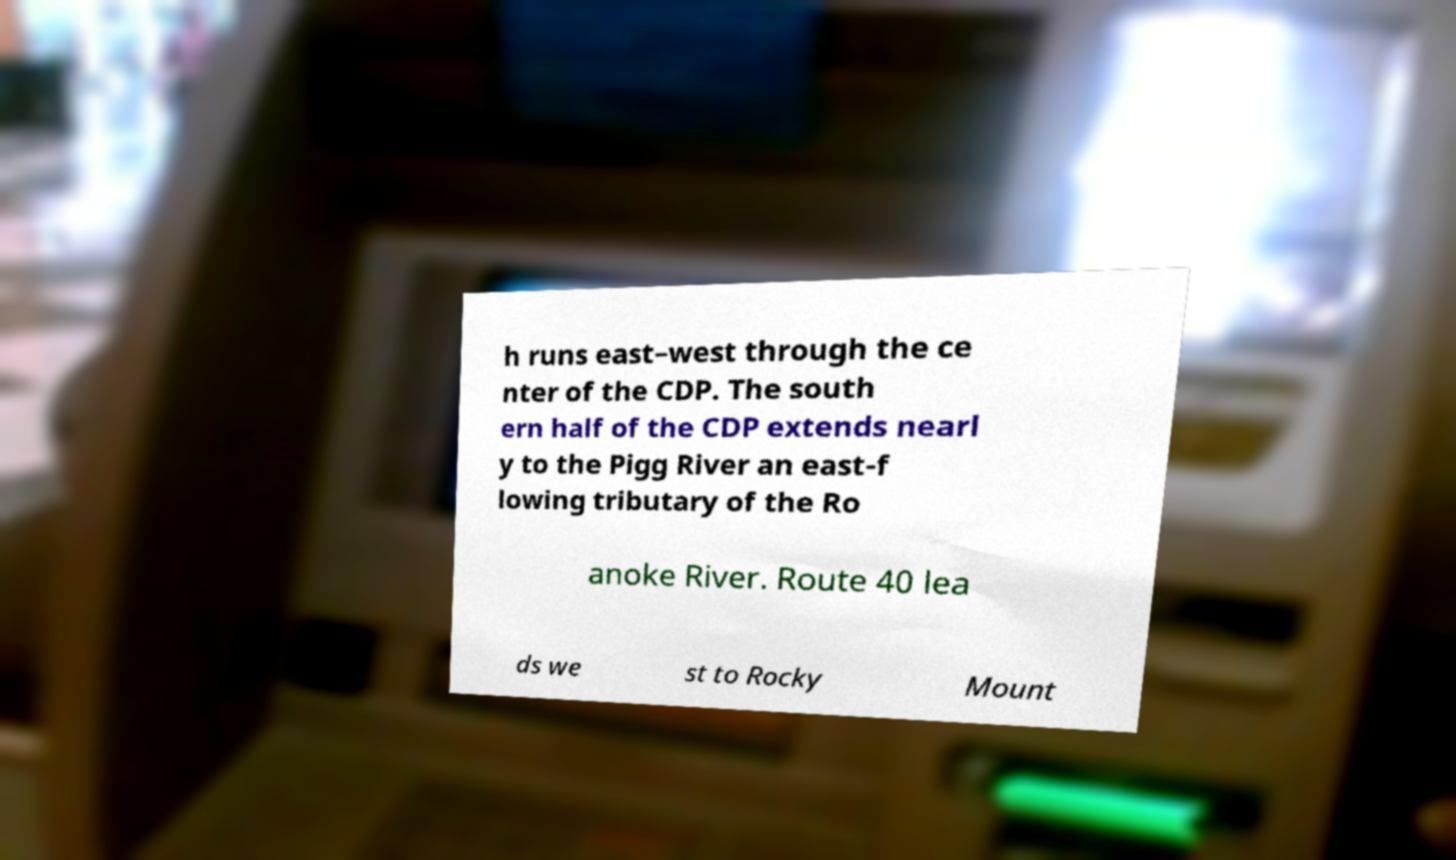Please identify and transcribe the text found in this image. h runs east–west through the ce nter of the CDP. The south ern half of the CDP extends nearl y to the Pigg River an east-f lowing tributary of the Ro anoke River. Route 40 lea ds we st to Rocky Mount 